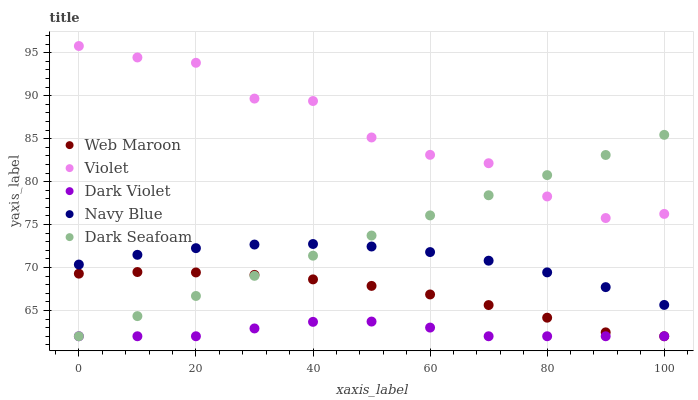Does Dark Violet have the minimum area under the curve?
Answer yes or no. Yes. Does Violet have the maximum area under the curve?
Answer yes or no. Yes. Does Dark Seafoam have the minimum area under the curve?
Answer yes or no. No. Does Dark Seafoam have the maximum area under the curve?
Answer yes or no. No. Is Dark Seafoam the smoothest?
Answer yes or no. Yes. Is Violet the roughest?
Answer yes or no. Yes. Is Web Maroon the smoothest?
Answer yes or no. No. Is Web Maroon the roughest?
Answer yes or no. No. Does Dark Seafoam have the lowest value?
Answer yes or no. Yes. Does Violet have the lowest value?
Answer yes or no. No. Does Violet have the highest value?
Answer yes or no. Yes. Does Dark Seafoam have the highest value?
Answer yes or no. No. Is Navy Blue less than Violet?
Answer yes or no. Yes. Is Navy Blue greater than Dark Violet?
Answer yes or no. Yes. Does Web Maroon intersect Dark Violet?
Answer yes or no. Yes. Is Web Maroon less than Dark Violet?
Answer yes or no. No. Is Web Maroon greater than Dark Violet?
Answer yes or no. No. Does Navy Blue intersect Violet?
Answer yes or no. No. 